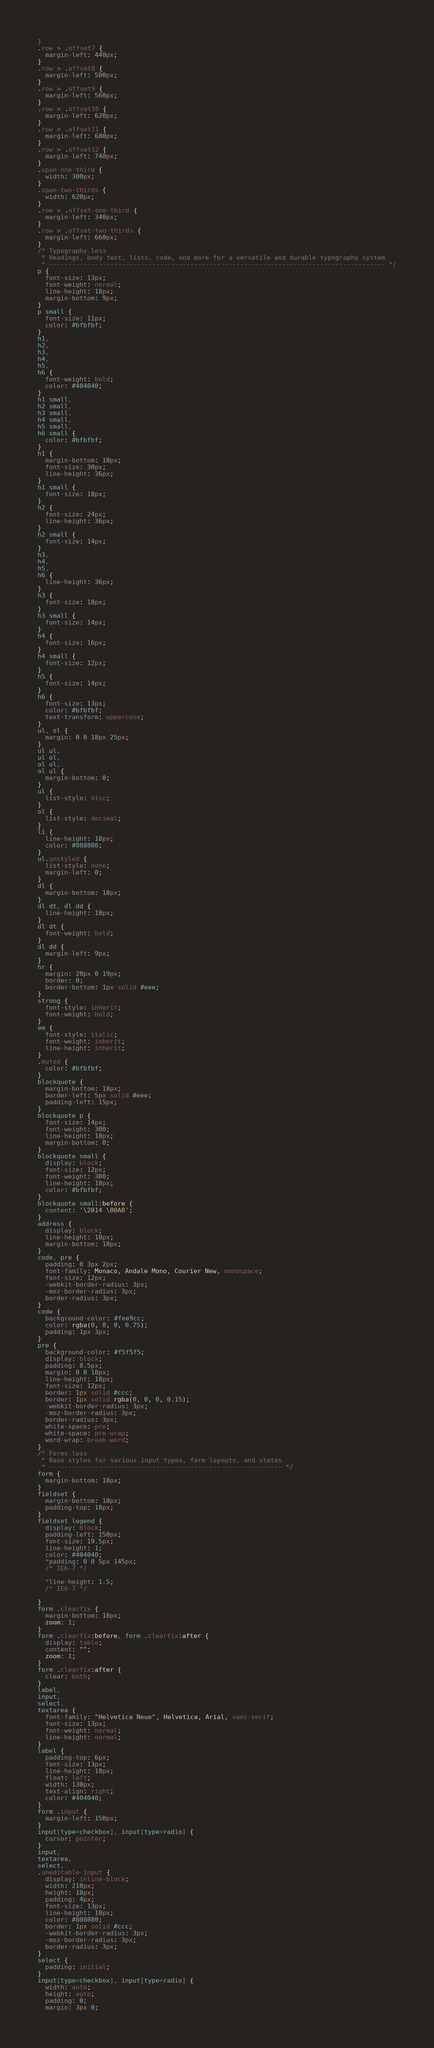Convert code to text. <code><loc_0><loc_0><loc_500><loc_500><_CSS_>}
.row > .offset7 {
  margin-left: 440px;
}
.row > .offset8 {
  margin-left: 500px;
}
.row > .offset9 {
  margin-left: 560px;
}
.row > .offset10 {
  margin-left: 620px;
}
.row > .offset11 {
  margin-left: 680px;
}
.row > .offset12 {
  margin-left: 740px;
}
.span-one-third {
  width: 300px;
}
.span-two-thirds {
  width: 620px;
}
.row > .offset-one-third {
  margin-left: 340px;
}
.row > .offset-two-thirds {
  margin-left: 660px;
}
/* Typography.less
 * Headings, body text, lists, code, and more for a versatile and durable typography system
 * ---------------------------------------------------------------------------------------- */
p {
  font-size: 13px;
  font-weight: normal;
  line-height: 18px;
  margin-bottom: 9px;
}
p small {
  font-size: 11px;
  color: #bfbfbf;
}
h1,
h2,
h3,
h4,
h5,
h6 {
  font-weight: bold;
  color: #404040;
}
h1 small,
h2 small,
h3 small,
h4 small,
h5 small,
h6 small {
  color: #bfbfbf;
}
h1 {
  margin-bottom: 18px;
  font-size: 30px;
  line-height: 36px;
}
h1 small {
  font-size: 18px;
}
h2 {
  font-size: 24px;
  line-height: 36px;
}
h2 small {
  font-size: 14px;
}
h3,
h4,
h5,
h6 {
  line-height: 36px;
}
h3 {
  font-size: 18px;
}
h3 small {
  font-size: 14px;
}
h4 {
  font-size: 16px;
}
h4 small {
  font-size: 12px;
}
h5 {
  font-size: 14px;
}
h6 {
  font-size: 13px;
  color: #bfbfbf;
  text-transform: uppercase;
}
ul, ol {
  margin: 0 0 18px 25px;
}
ul ul,
ul ol,
ol ol,
ol ul {
  margin-bottom: 0;
}
ul {
  list-style: disc;
}
ol {
  list-style: decimal;
}
li {
  line-height: 18px;
  color: #808080;
}
ul.unstyled {
  list-style: none;
  margin-left: 0;
}
dl {
  margin-bottom: 18px;
}
dl dt, dl dd {
  line-height: 18px;
}
dl dt {
  font-weight: bold;
}
dl dd {
  margin-left: 9px;
}
hr {
  margin: 20px 0 19px;
  border: 0;
  border-bottom: 1px solid #eee;
}
strong {
  font-style: inherit;
  font-weight: bold;
}
em {
  font-style: italic;
  font-weight: inherit;
  line-height: inherit;
}
.muted {
  color: #bfbfbf;
}
blockquote {
  margin-bottom: 18px;
  border-left: 5px solid #eee;
  padding-left: 15px;
}
blockquote p {
  font-size: 14px;
  font-weight: 300;
  line-height: 18px;
  margin-bottom: 0;
}
blockquote small {
  display: block;
  font-size: 12px;
  font-weight: 300;
  line-height: 18px;
  color: #bfbfbf;
}
blockquote small:before {
  content: '\2014 \00A0';
}
address {
  display: block;
  line-height: 18px;
  margin-bottom: 18px;
}
code, pre {
  padding: 0 3px 2px;
  font-family: Monaco, Andale Mono, Courier New, monospace;
  font-size: 12px;
  -webkit-border-radius: 3px;
  -moz-border-radius: 3px;
  border-radius: 3px;
}
code {
  background-color: #fee9cc;
  color: rgba(0, 0, 0, 0.75);
  padding: 1px 3px;
}
pre {
  background-color: #f5f5f5;
  display: block;
  padding: 8.5px;
  margin: 0 0 18px;
  line-height: 18px;
  font-size: 12px;
  border: 1px solid #ccc;
  border: 1px solid rgba(0, 0, 0, 0.15);
  -webkit-border-radius: 3px;
  -moz-border-radius: 3px;
  border-radius: 3px;
  white-space: pre;
  white-space: pre-wrap;
  word-wrap: break-word;
}
/* Forms.less
 * Base styles for various input types, form layouts, and states
 * ------------------------------------------------------------- */
form {
  margin-bottom: 18px;
}
fieldset {
  margin-bottom: 18px;
  padding-top: 18px;
}
fieldset legend {
  display: block;
  padding-left: 150px;
  font-size: 19.5px;
  line-height: 1;
  color: #404040;
  *padding: 0 0 5px 145px;
  /* IE6-7 */

  *line-height: 1.5;
  /* IE6-7 */

}
form .clearfix {
  margin-bottom: 18px;
  zoom: 1;
}
form .clearfix:before, form .clearfix:after {
  display: table;
  content: "";
  zoom: 1;
}
form .clearfix:after {
  clear: both;
}
label,
input,
select,
textarea {
  font-family: "Helvetica Neue", Helvetica, Arial, sans-serif;
  font-size: 13px;
  font-weight: normal;
  line-height: normal;
}
label {
  padding-top: 6px;
  font-size: 13px;
  line-height: 18px;
  float: left;
  width: 130px;
  text-align: right;
  color: #404040;
}
form .input {
  margin-left: 150px;
}
input[type=checkbox], input[type=radio] {
  cursor: pointer;
}
input,
textarea,
select,
.uneditable-input {
  display: inline-block;
  width: 210px;
  height: 18px;
  padding: 4px;
  font-size: 13px;
  line-height: 18px;
  color: #808080;
  border: 1px solid #ccc;
  -webkit-border-radius: 3px;
  -moz-border-radius: 3px;
  border-radius: 3px;
}
select {
  padding: initial;
}
input[type=checkbox], input[type=radio] {
  width: auto;
  height: auto;
  padding: 0;
  margin: 3px 0;</code> 